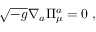<formula> <loc_0><loc_0><loc_500><loc_500>\sqrt { - g } \nabla _ { a } \Pi _ { \mu } ^ { a } = 0 \ ,</formula> 